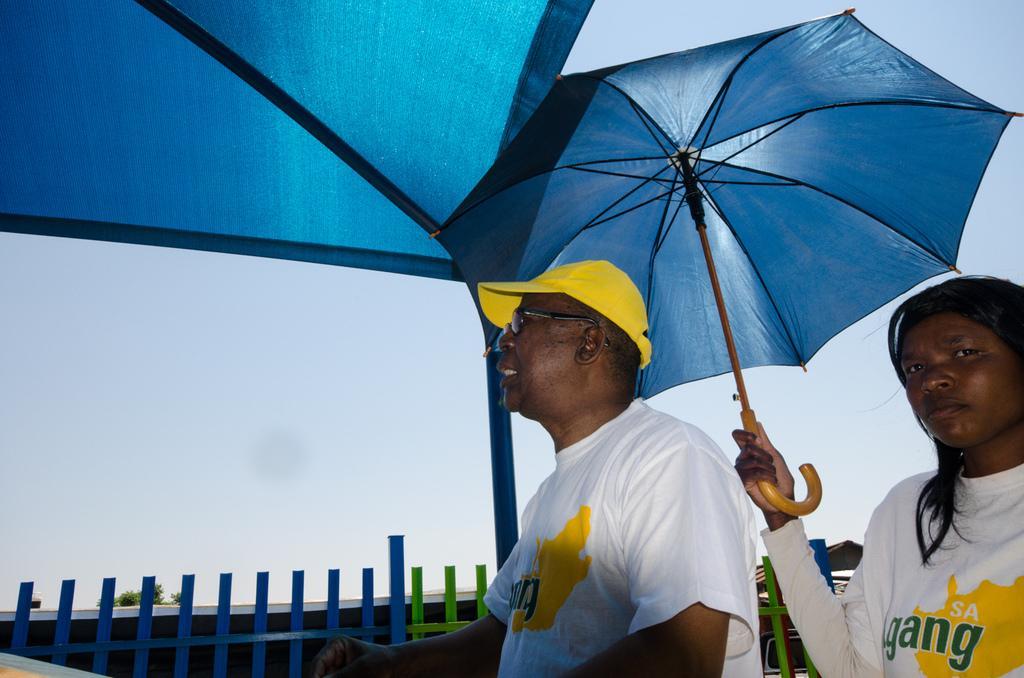In one or two sentences, can you explain what this image depicts? In this picture we can see a man and a woman, this woman is holding an umbrella, it looks like a tent at the top of the picture, there is railing and a plant in the background, we can see the sky at the right top of the picture. 